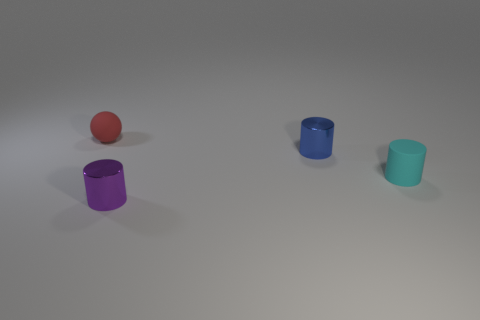Subtract all tiny cyan cylinders. How many cylinders are left? 2 Subtract all blue cylinders. How many cylinders are left? 2 Subtract 1 cylinders. How many cylinders are left? 2 Add 3 tiny cyan objects. How many objects exist? 7 Subtract all balls. How many objects are left? 3 Subtract all gray cylinders. Subtract all red cubes. How many cylinders are left? 3 Subtract all purple cubes. How many purple spheres are left? 0 Subtract all green rubber things. Subtract all tiny metallic things. How many objects are left? 2 Add 4 small purple objects. How many small purple objects are left? 5 Add 3 cyan rubber cubes. How many cyan rubber cubes exist? 3 